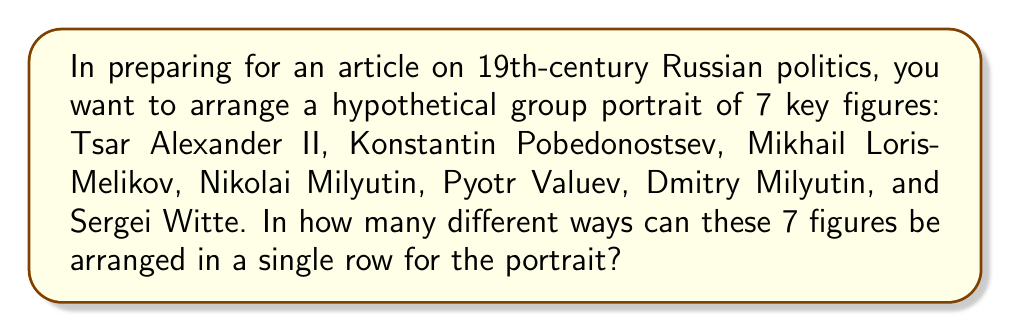Solve this math problem. To solve this problem, we need to use the concept of permutations from combinatorics. When arranging a fixed number of distinct objects in a specific order, we use the following approach:

1) We have 7 distinct political figures to arrange.

2) For the first position, we have 7 choices, as any of the 7 figures can be placed there.

3) After placing the first figure, we have 6 remaining figures for the second position.

4) For the third position, we'll have 5 choices, and so on.

5) This pattern continues until we place the last figure, for which we'll have only 1 choice.

6) Mathematically, this scenario is represented by the permutation formula:

   $$P(7) = 7!$$

   Where $7!$ (read as "7 factorial") is the product of all positive integers less than or equal to 7.

7) Expanding this:

   $$7! = 7 \times 6 \times 5 \times 4 \times 3 \times 2 \times 1 = 5040$$

Therefore, there are 5040 different ways to arrange these 7 key figures of 19th-century Russian politics in a single row for the group portrait.
Answer: 5040 